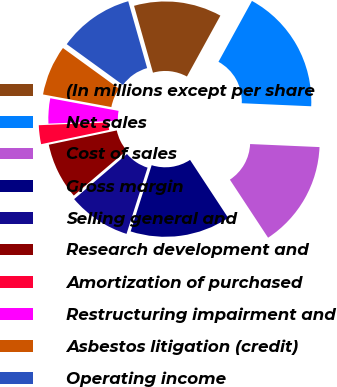Convert chart. <chart><loc_0><loc_0><loc_500><loc_500><pie_chart><fcel>(In millions except per share<fcel>Net sales<fcel>Cost of sales<fcel>Gross margin<fcel>Selling general and<fcel>Research development and<fcel>Amortization of purchased<fcel>Restructuring impairment and<fcel>Asbestos litigation (credit)<fcel>Operating income<nl><fcel>12.39%<fcel>17.7%<fcel>15.04%<fcel>14.16%<fcel>8.85%<fcel>7.96%<fcel>2.66%<fcel>3.54%<fcel>7.08%<fcel>10.62%<nl></chart> 